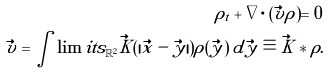Convert formula to latex. <formula><loc_0><loc_0><loc_500><loc_500>\rho _ { t } + \nabla \cdot ( \vec { v } \rho ) = 0 \\ \vec { v } = \int \lim i t s _ { \mathbb { R } ^ { 2 } } \vec { K } ( | \vec { x } - \vec { y } | ) \rho ( \vec { y } ) \, d \vec { y } \equiv \vec { K } * \rho .</formula> 